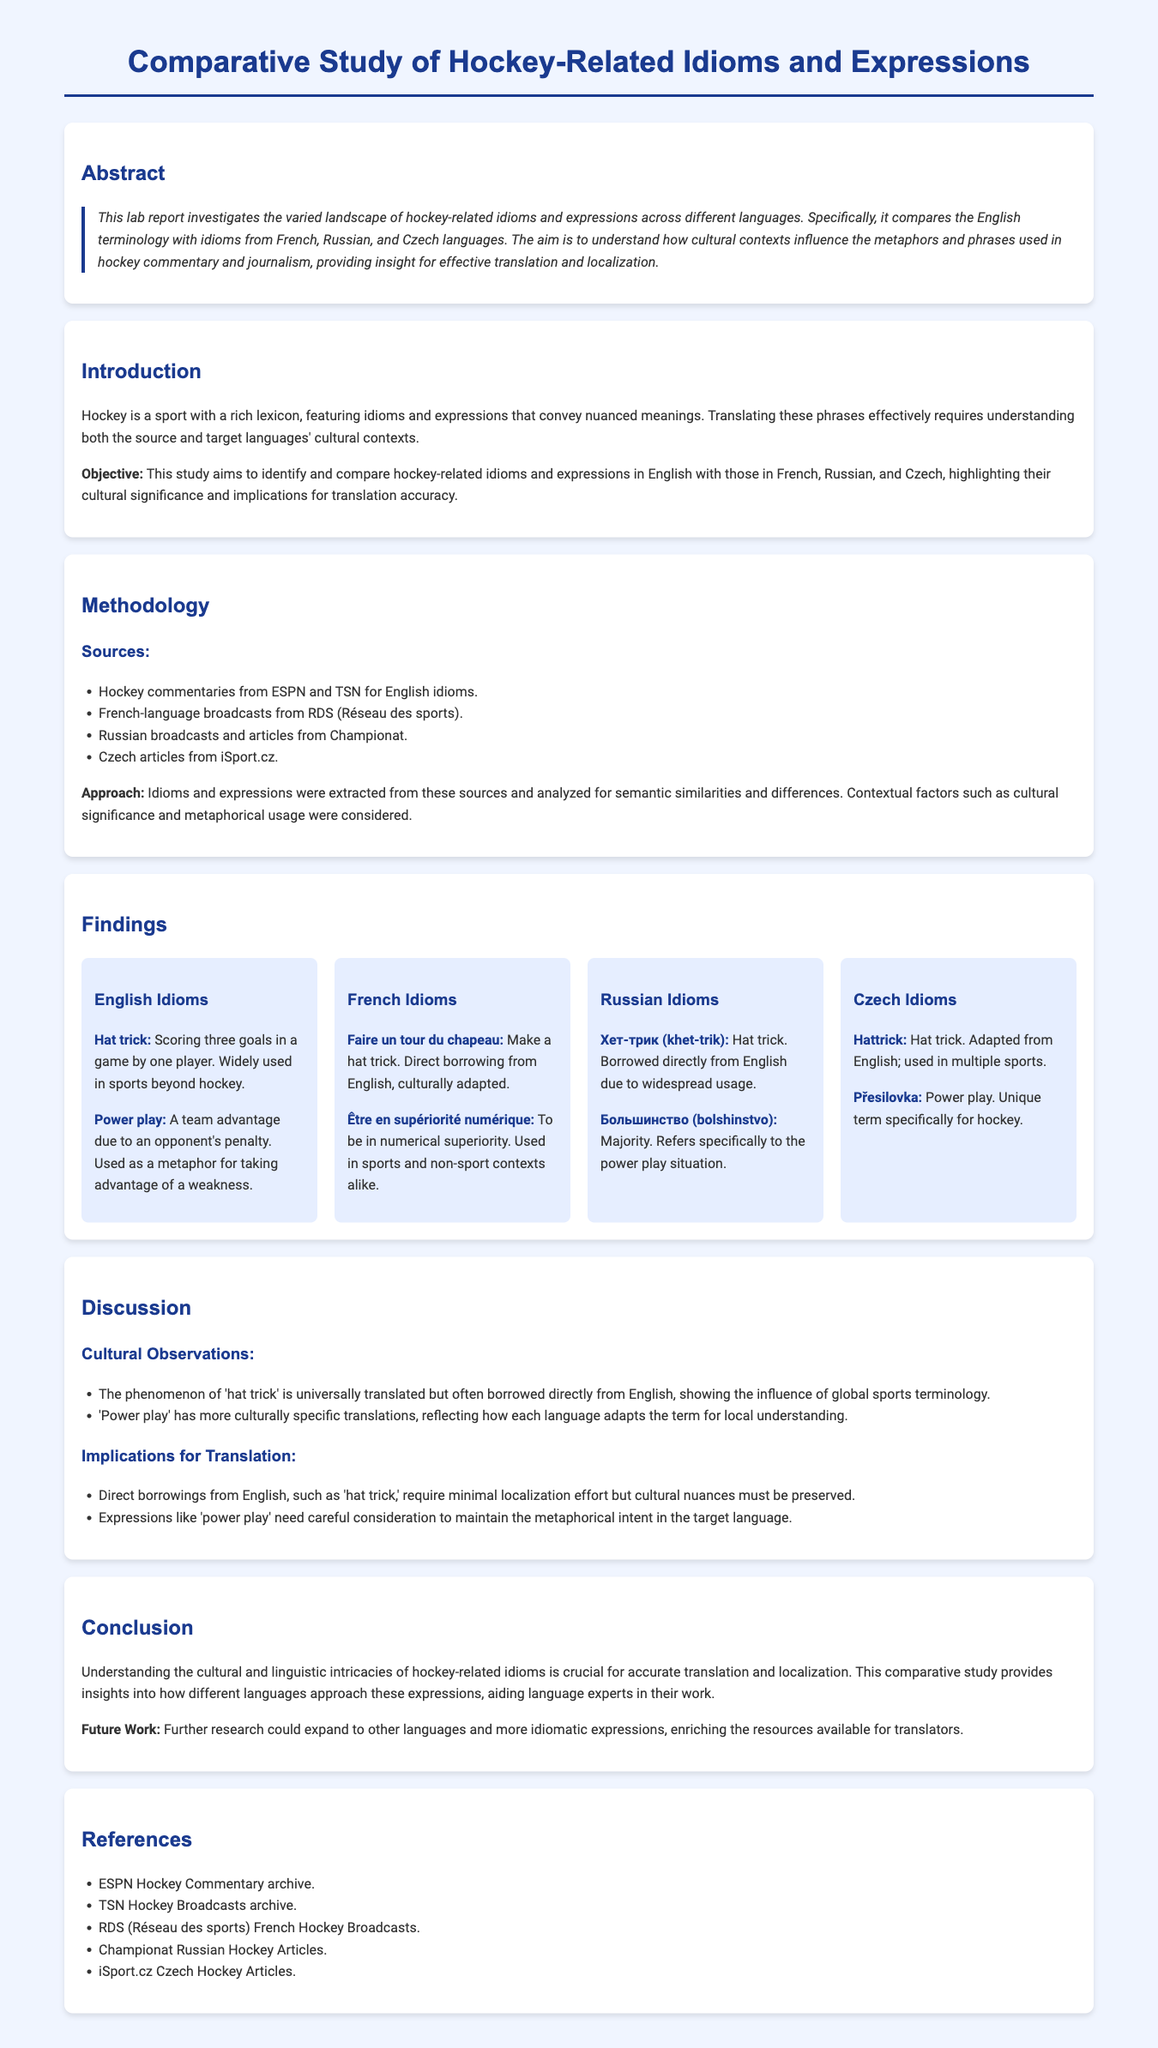What is the primary aim of this study? The primary aim of the study is to identify and compare hockey-related idioms and expressions in English with those in French, Russian, and Czech, highlighting their cultural significance and implications for translation accuracy.
Answer: To identify and compare hockey-related idioms and expressions Which idiom refers to scoring three goals in a game? The idiom that refers to scoring three goals in a game is defined in the findings section under English idioms.
Answer: Hat trick What is the French term for 'power play'? The French term for 'power play' is indicated among the French idioms listed in the findings section.
Answer: Être en supériorité numérique Which source was used for Russian idioms? The source for Russian idioms was gathered from specific broadcasts and articles as mentioned in the methodology section.
Answer: Championat How many languages are compared in this study? The document mentions specific languages that were part of the comparative study in the objectives.
Answer: Three What section discusses cultural significance? The section that discusses cultural significance is the one that analyzes cultural observations and implications for translation.
Answer: Discussion What term is used universally for 'hat trick' in Russian? The term used universally in Russian for 'hat trick' is mentioned in the findings section.
Answer: Хет-трик What is the future work suggested in the conclusion? The conclusion notes specific directions for further research to expand the scope of the study.
Answer: Further research could expand to other languages and more idiomatic expressions 